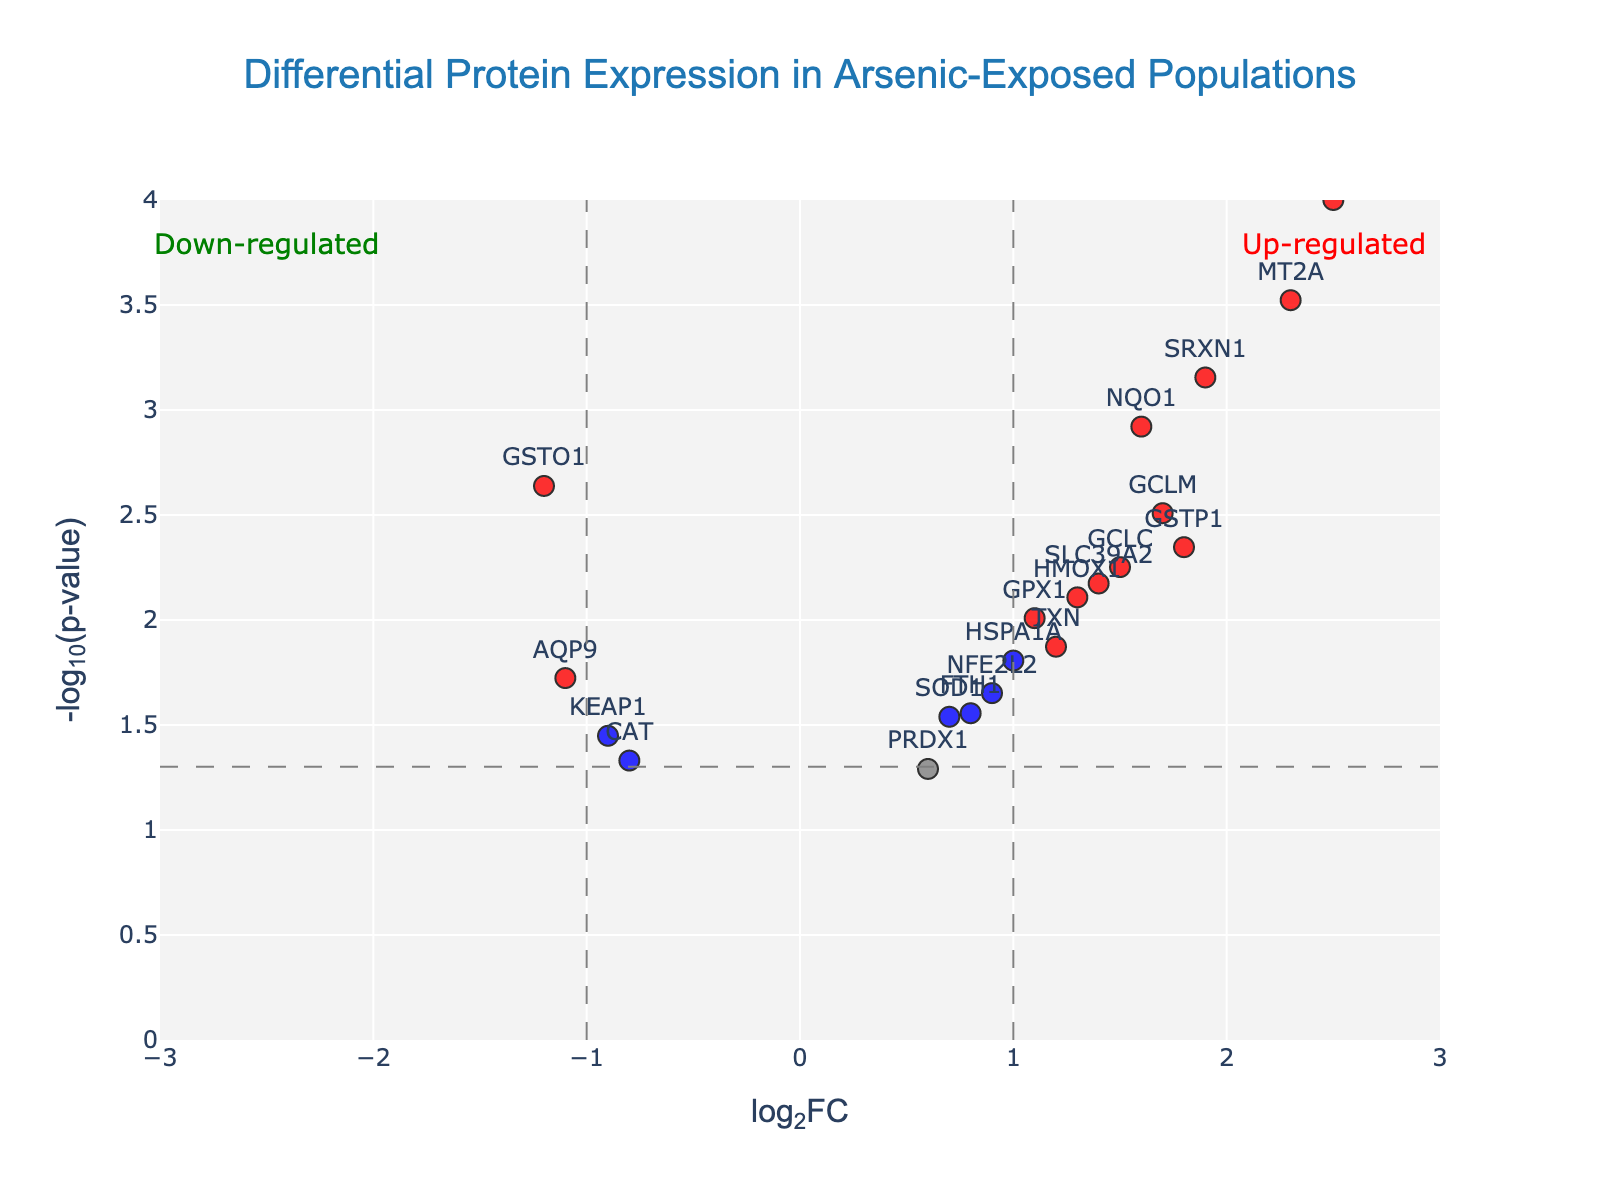What is the title of the plot? The title is displayed at the top of the figure, indicating the main subject of the plot.
Answer: Differential Protein Expression in Arsenic-Exposed Populations How many proteins showed statistically significant differential expression? The proteins that are colored red or blue indicate statistically significant differential expression (p-value < 0.05).
Answer: 15 Which proteins are considered up-regulated according to the plot? Up-regulated proteins are those with log2FC > 0 and a significant p-value (red color).
Answer: MT1A, GSTP1, HMOX1, NQO1, GPX1, SRXN1, TXN, GCLC, GCLM, SLC39A2, MT2A, HSPA1A Which proteins have the lowest p-values? The proteins with the highest values on the y-axis (since the y-axis is -log10(p-value)) have the lowest p-values.
Answer: MT1A, MT2A, SRXN1 Are there more up-regulated or down-regulated proteins among the statistically significant ones? By counting the red and green dots (significant proteins), we can compare their numbers.
Answer: Up-regulated What ranges do the log2FC values of the significant down-regulated proteins fall into? Significant down-regulated proteins are colored red and have a log2FC value of less than -1.
Answer: -1.2 to -0.9 What does the color grey represent in the plot? Grey is used to indicate proteins that are not statistically significant.
Answer: Non-significant proteins Which proteins have a log2FC greater than 2? The x-axis represents log2FC, so proteins plotted with x > 2 are identified.
Answer: MT1A, MT2A What thresholds are used to determine significance in terms of p-value and log2FC? The p-value threshold is indicated by the horizontal dashed line, and the log2FC threshold by the vertical dashed lines. The p-value threshold is 0.05, and the log2FC threshold is ±1.
Answer: p-value < 0.05, log2FC > 1 or < -1 How were up- and down-regulated proteins visually differentiated on the plot? Up-regulated proteins are colored red, down-regulated proteins are colored green, and non-significant proteins are grey.
Answer: Colors red and green 